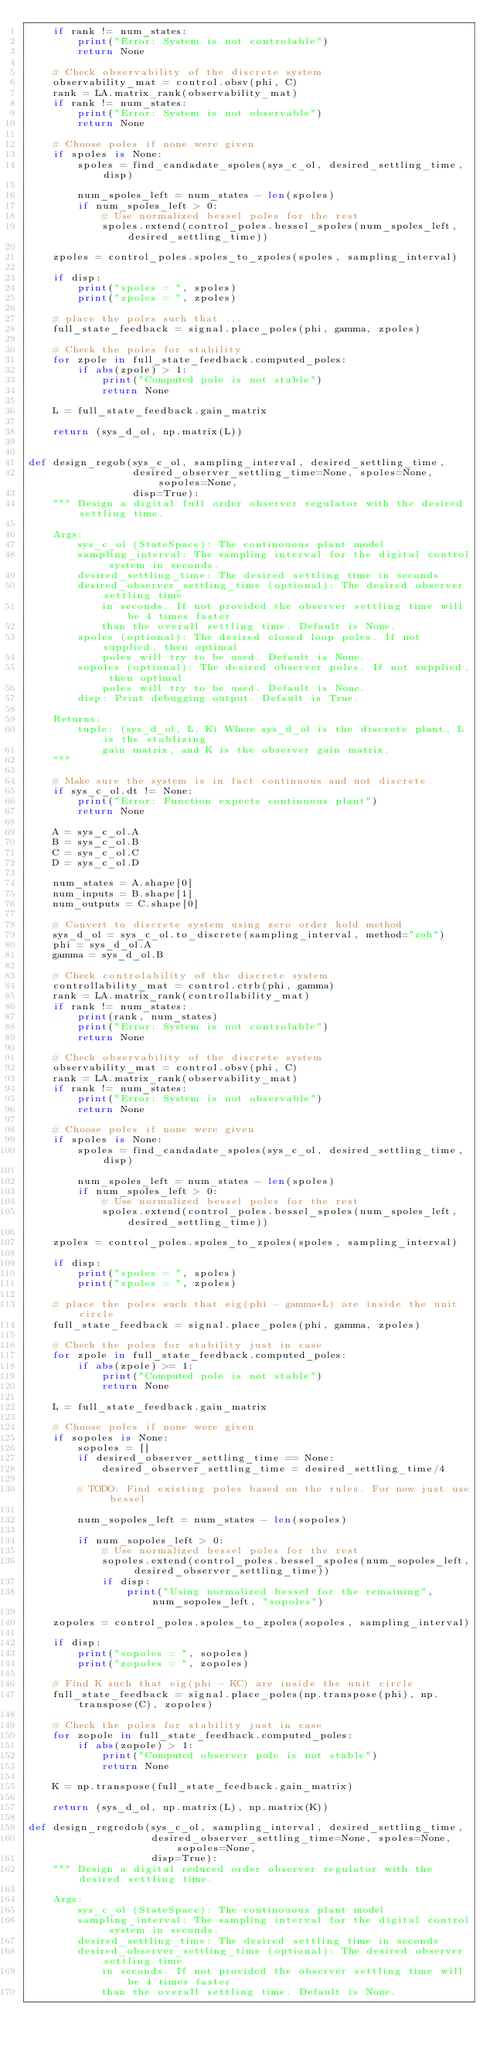Convert code to text. <code><loc_0><loc_0><loc_500><loc_500><_Python_>    if rank != num_states:
        print("Error: System is not controlable")
        return None

    # Check observability of the discrete system
    observability_mat = control.obsv(phi, C)
    rank = LA.matrix_rank(observability_mat)
    if rank != num_states:
        print("Error: System is not observable")
        return None

    # Choose poles if none were given
    if spoles is None:
        spoles = find_candadate_spoles(sys_c_ol, desired_settling_time, disp)
        
        num_spoles_left = num_states - len(spoles)
        if num_spoles_left > 0:
            # Use normalized bessel poles for the rest
            spoles.extend(control_poles.bessel_spoles(num_spoles_left, desired_settling_time))

    zpoles = control_poles.spoles_to_zpoles(spoles, sampling_interval)

    if disp:
        print("spoles = ", spoles)
        print("zpoles = ", zpoles)

    # place the poles such that ...
    full_state_feedback = signal.place_poles(phi, gamma, zpoles)
    
    # Check the poles for stability
    for zpole in full_state_feedback.computed_poles:
        if abs(zpole) > 1:
            print("Computed pole is not stable")
            return None
    
    L = full_state_feedback.gain_matrix

    return (sys_d_ol, np.matrix(L))


def design_regob(sys_c_ol, sampling_interval, desired_settling_time,
                 desired_observer_settling_time=None, spoles=None, sopoles=None,
                 disp=True):
    """ Design a digital full order observer regulator with the desired settling time.
    
    Args:
        sys_c_ol (StateSpace): The continouous plant model
        sampling_interval: The sampling interval for the digital control system in seconds.
        desired_settling_time: The desired settling time in seconds
        desired_observer_settling_time (optional): The desired observer settling time
            in seconds. If not provided the observer settling time will be 4 times faster
            than the overall settling time. Default is None.
        spoles (optional): The desired closed loop poles. If not supplied, then optimal
            poles will try to be used. Default is None.
        sopoles (optional): The desired observer poles. If not supplied, then optimal
            poles will try to be used. Default is None.
        disp: Print debugging output. Default is True.

    Returns:
        tuple: (sys_d_ol, L, K) Where sys_d_ol is the discrete plant, L is the stablizing
            gain matrix, and K is the observer gain matrix.
    """

    # Make sure the system is in fact continuous and not discrete
    if sys_c_ol.dt != None:
        print("Error: Function expects continuous plant")
        return None

    A = sys_c_ol.A
    B = sys_c_ol.B
    C = sys_c_ol.C
    D = sys_c_ol.D
    
    num_states = A.shape[0]
    num_inputs = B.shape[1]
    num_outputs = C.shape[0]
    
    # Convert to discrete system using zero order hold method
    sys_d_ol = sys_c_ol.to_discrete(sampling_interval, method="zoh")
    phi = sys_d_ol.A
    gamma = sys_d_ol.B

    # Check controlability of the discrete system
    controllability_mat = control.ctrb(phi, gamma)
    rank = LA.matrix_rank(controllability_mat)
    if rank != num_states:
        print(rank, num_states)
        print("Error: System is not controlable")
        return None

    # Check observability of the discrete system
    observability_mat = control.obsv(phi, C)
    rank = LA.matrix_rank(observability_mat)
    if rank != num_states:
        print("Error: System is not observable")
        return None
    
    # Choose poles if none were given
    if spoles is None:
        spoles = find_candadate_spoles(sys_c_ol, desired_settling_time, disp)
        
        num_spoles_left = num_states - len(spoles)
        if num_spoles_left > 0:
            # Use normalized bessel poles for the rest
            spoles.extend(control_poles.bessel_spoles(num_spoles_left, desired_settling_time))

    zpoles = control_poles.spoles_to_zpoles(spoles, sampling_interval)

    if disp:
        print("spoles = ", spoles)
        print("zpoles = ", zpoles)

    # place the poles such that eig(phi - gamma*L) are inside the unit circle
    full_state_feedback = signal.place_poles(phi, gamma, zpoles)

    # Check the poles for stability just in case
    for zpole in full_state_feedback.computed_poles:
        if abs(zpole) >= 1:
            print("Computed pole is not stable")
            return None
    
    L = full_state_feedback.gain_matrix

    # Choose poles if none were given
    if sopoles is None:
        sopoles = []
        if desired_observer_settling_time == None:
            desired_observer_settling_time = desired_settling_time/4
        
        # TODO: Find existing poles based on the rules. For now just use bessel
        
        num_sopoles_left = num_states - len(sopoles)
        
        if num_sopoles_left > 0:
            # Use normalized bessel poles for the rest
            sopoles.extend(control_poles.bessel_spoles(num_sopoles_left, desired_observer_settling_time))
            if disp:
                print("Using normalized bessel for the remaining", num_sopoles_left, "sopoles")
    
    zopoles = control_poles.spoles_to_zpoles(sopoles, sampling_interval)
    
    if disp:
        print("sopoles = ", sopoles)
        print("zopoles = ", zopoles)

    # Find K such that eig(phi - KC) are inside the unit circle
    full_state_feedback = signal.place_poles(np.transpose(phi), np.transpose(C), zopoles)
    
    # Check the poles for stability just in case
    for zopole in full_state_feedback.computed_poles:
        if abs(zopole) > 1:
            print("Computed observer pole is not stable")
            return None
    
    K = np.transpose(full_state_feedback.gain_matrix)

    return (sys_d_ol, np.matrix(L), np.matrix(K))

def design_regredob(sys_c_ol, sampling_interval, desired_settling_time,
                    desired_observer_settling_time=None, spoles=None, sopoles=None,
                    disp=True):
    """ Design a digital reduced order observer regulator with the desired settling time.
    
    Args:
        sys_c_ol (StateSpace): The continouous plant model
        sampling_interval: The sampling interval for the digital control system in seconds.
        desired_settling_time: The desired settling time in seconds
        desired_observer_settling_time (optional): The desired observer settling time
            in seconds. If not provided the observer settling time will be 4 times faster
            than the overall settling time. Default is None.</code> 